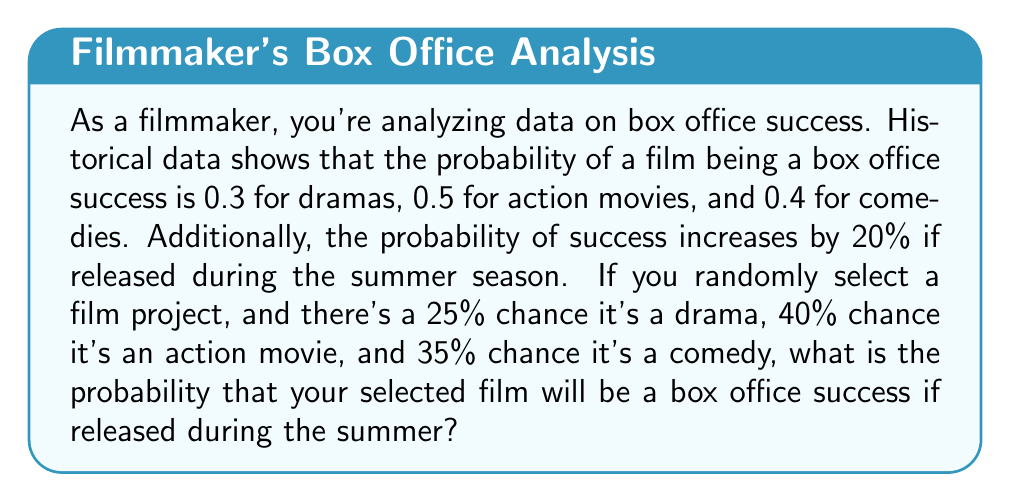Could you help me with this problem? Let's approach this step-by-step:

1) First, let's define our events:
   D: Drama, A: Action, C: Comedy
   S: Success, Su: Summer release

2) Given probabilities:
   $P(S|D) = 0.3$, $P(S|A) = 0.5$, $P(S|C) = 0.4$
   $P(D) = 0.25$, $P(A) = 0.40$, $P(C) = 0.35$

3) The summer release increases success probability by 20%. We can express this as:
   $P(S|D,Su) = 0.3 \times 1.2 = 0.36$
   $P(S|A,Su) = 0.5 \times 1.2 = 0.60$
   $P(S|C,Su) = 0.4 \times 1.2 = 0.48$

4) We can use the law of total probability:
   $P(S|Su) = P(S|D,Su)P(D) + P(S|A,Su)P(A) + P(S|C,Su)P(C)$

5) Substituting our values:
   $P(S|Su) = 0.36 \times 0.25 + 0.60 \times 0.40 + 0.48 \times 0.35$

6) Calculating:
   $P(S|Su) = 0.09 + 0.24 + 0.168 = 0.498$

Therefore, the probability of the selected film being a box office success if released during summer is 0.498 or 49.8%.
Answer: The probability that the selected film will be a box office success if released during the summer is 0.498 or 49.8%. 